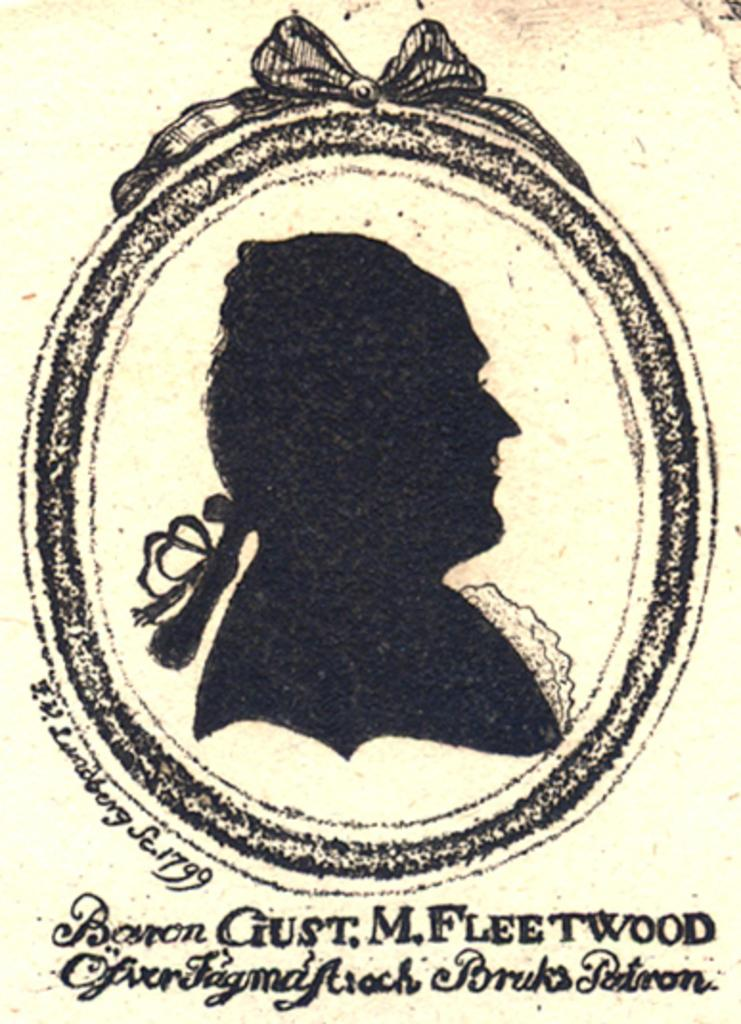What is depicted in the picture? There is an illustration of a woman in the picture. What might the purpose of the picture be? It might be a photo frame, as suggested by the facts. What can be found at the bottom of the picture? There is text written at the bottom of the picture. What is the color of the background in the image? The background of the image is white in color. What type of hammer is being used to improve the acoustics in the image? There is no hammer or mention of acoustics in the image; it features an illustration of a woman with text at the bottom and a white background. 